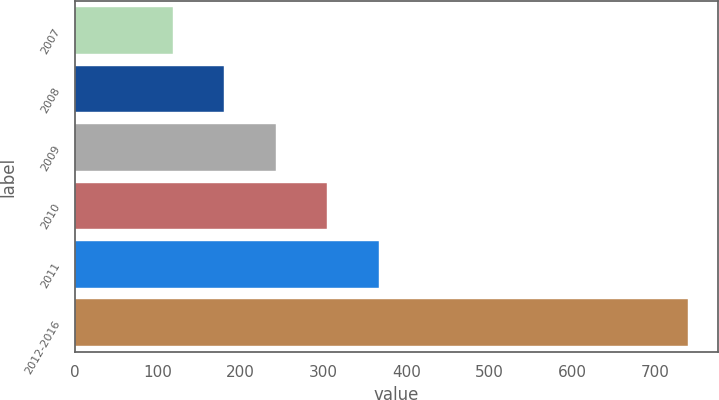Convert chart. <chart><loc_0><loc_0><loc_500><loc_500><bar_chart><fcel>2007<fcel>2008<fcel>2009<fcel>2010<fcel>2011<fcel>2012-2016<nl><fcel>118<fcel>180.1<fcel>242.2<fcel>304.3<fcel>366.4<fcel>739<nl></chart> 